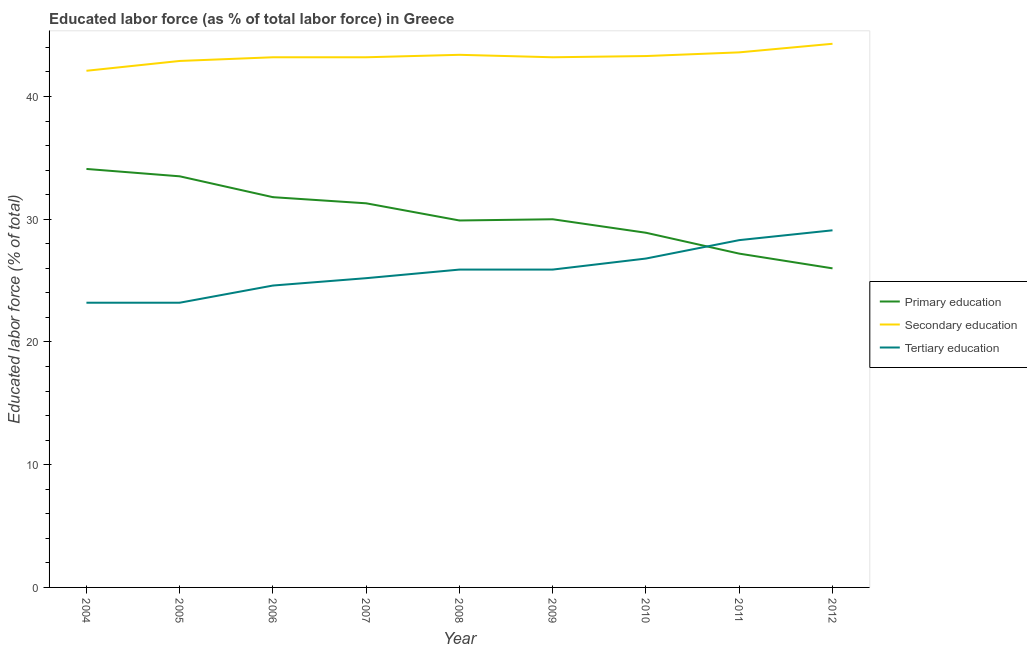How many different coloured lines are there?
Make the answer very short. 3. Does the line corresponding to percentage of labor force who received secondary education intersect with the line corresponding to percentage of labor force who received primary education?
Your answer should be very brief. No. What is the percentage of labor force who received tertiary education in 2011?
Offer a very short reply. 28.3. Across all years, what is the maximum percentage of labor force who received tertiary education?
Provide a short and direct response. 29.1. Across all years, what is the minimum percentage of labor force who received secondary education?
Give a very brief answer. 42.1. In which year was the percentage of labor force who received tertiary education maximum?
Your answer should be compact. 2012. What is the total percentage of labor force who received tertiary education in the graph?
Keep it short and to the point. 232.2. What is the difference between the percentage of labor force who received tertiary education in 2007 and that in 2011?
Give a very brief answer. -3.1. What is the difference between the percentage of labor force who received secondary education in 2007 and the percentage of labor force who received primary education in 2004?
Ensure brevity in your answer.  9.1. What is the average percentage of labor force who received primary education per year?
Offer a terse response. 30.3. In the year 2010, what is the difference between the percentage of labor force who received secondary education and percentage of labor force who received primary education?
Make the answer very short. 14.4. In how many years, is the percentage of labor force who received primary education greater than 6 %?
Your response must be concise. 9. What is the ratio of the percentage of labor force who received tertiary education in 2011 to that in 2012?
Keep it short and to the point. 0.97. Is the percentage of labor force who received secondary education in 2007 less than that in 2008?
Provide a short and direct response. Yes. What is the difference between the highest and the second highest percentage of labor force who received primary education?
Your answer should be compact. 0.6. What is the difference between the highest and the lowest percentage of labor force who received secondary education?
Offer a very short reply. 2.2. In how many years, is the percentage of labor force who received secondary education greater than the average percentage of labor force who received secondary education taken over all years?
Your response must be concise. 4. Is the percentage of labor force who received secondary education strictly less than the percentage of labor force who received primary education over the years?
Provide a succinct answer. No. Are the values on the major ticks of Y-axis written in scientific E-notation?
Your answer should be compact. No. Does the graph contain grids?
Give a very brief answer. No. Where does the legend appear in the graph?
Give a very brief answer. Center right. How many legend labels are there?
Your answer should be very brief. 3. What is the title of the graph?
Give a very brief answer. Educated labor force (as % of total labor force) in Greece. Does "Natural gas sources" appear as one of the legend labels in the graph?
Keep it short and to the point. No. What is the label or title of the X-axis?
Offer a terse response. Year. What is the label or title of the Y-axis?
Make the answer very short. Educated labor force (% of total). What is the Educated labor force (% of total) in Primary education in 2004?
Provide a succinct answer. 34.1. What is the Educated labor force (% of total) in Secondary education in 2004?
Provide a succinct answer. 42.1. What is the Educated labor force (% of total) in Tertiary education in 2004?
Provide a succinct answer. 23.2. What is the Educated labor force (% of total) of Primary education in 2005?
Your answer should be very brief. 33.5. What is the Educated labor force (% of total) in Secondary education in 2005?
Provide a short and direct response. 42.9. What is the Educated labor force (% of total) of Tertiary education in 2005?
Your response must be concise. 23.2. What is the Educated labor force (% of total) of Primary education in 2006?
Provide a succinct answer. 31.8. What is the Educated labor force (% of total) of Secondary education in 2006?
Offer a very short reply. 43.2. What is the Educated labor force (% of total) of Tertiary education in 2006?
Keep it short and to the point. 24.6. What is the Educated labor force (% of total) of Primary education in 2007?
Provide a short and direct response. 31.3. What is the Educated labor force (% of total) of Secondary education in 2007?
Provide a succinct answer. 43.2. What is the Educated labor force (% of total) in Tertiary education in 2007?
Provide a succinct answer. 25.2. What is the Educated labor force (% of total) in Primary education in 2008?
Ensure brevity in your answer.  29.9. What is the Educated labor force (% of total) of Secondary education in 2008?
Your answer should be compact. 43.4. What is the Educated labor force (% of total) of Tertiary education in 2008?
Keep it short and to the point. 25.9. What is the Educated labor force (% of total) of Secondary education in 2009?
Provide a short and direct response. 43.2. What is the Educated labor force (% of total) in Tertiary education in 2009?
Your answer should be very brief. 25.9. What is the Educated labor force (% of total) of Primary education in 2010?
Ensure brevity in your answer.  28.9. What is the Educated labor force (% of total) of Secondary education in 2010?
Your answer should be very brief. 43.3. What is the Educated labor force (% of total) in Tertiary education in 2010?
Your answer should be compact. 26.8. What is the Educated labor force (% of total) in Primary education in 2011?
Your answer should be very brief. 27.2. What is the Educated labor force (% of total) of Secondary education in 2011?
Provide a short and direct response. 43.6. What is the Educated labor force (% of total) in Tertiary education in 2011?
Offer a terse response. 28.3. What is the Educated labor force (% of total) in Primary education in 2012?
Ensure brevity in your answer.  26. What is the Educated labor force (% of total) in Secondary education in 2012?
Your answer should be compact. 44.3. What is the Educated labor force (% of total) of Tertiary education in 2012?
Provide a succinct answer. 29.1. Across all years, what is the maximum Educated labor force (% of total) in Primary education?
Offer a very short reply. 34.1. Across all years, what is the maximum Educated labor force (% of total) of Secondary education?
Make the answer very short. 44.3. Across all years, what is the maximum Educated labor force (% of total) in Tertiary education?
Your response must be concise. 29.1. Across all years, what is the minimum Educated labor force (% of total) in Secondary education?
Your answer should be compact. 42.1. Across all years, what is the minimum Educated labor force (% of total) in Tertiary education?
Offer a very short reply. 23.2. What is the total Educated labor force (% of total) in Primary education in the graph?
Your response must be concise. 272.7. What is the total Educated labor force (% of total) of Secondary education in the graph?
Ensure brevity in your answer.  389.2. What is the total Educated labor force (% of total) in Tertiary education in the graph?
Ensure brevity in your answer.  232.2. What is the difference between the Educated labor force (% of total) of Tertiary education in 2004 and that in 2005?
Your response must be concise. 0. What is the difference between the Educated labor force (% of total) of Primary education in 2004 and that in 2007?
Provide a short and direct response. 2.8. What is the difference between the Educated labor force (% of total) in Tertiary education in 2004 and that in 2007?
Offer a terse response. -2. What is the difference between the Educated labor force (% of total) of Primary education in 2004 and that in 2009?
Ensure brevity in your answer.  4.1. What is the difference between the Educated labor force (% of total) of Secondary education in 2004 and that in 2009?
Ensure brevity in your answer.  -1.1. What is the difference between the Educated labor force (% of total) of Tertiary education in 2004 and that in 2009?
Keep it short and to the point. -2.7. What is the difference between the Educated labor force (% of total) of Tertiary education in 2004 and that in 2010?
Keep it short and to the point. -3.6. What is the difference between the Educated labor force (% of total) in Primary education in 2004 and that in 2011?
Ensure brevity in your answer.  6.9. What is the difference between the Educated labor force (% of total) in Tertiary education in 2004 and that in 2011?
Offer a very short reply. -5.1. What is the difference between the Educated labor force (% of total) of Primary education in 2004 and that in 2012?
Offer a very short reply. 8.1. What is the difference between the Educated labor force (% of total) of Primary education in 2005 and that in 2006?
Give a very brief answer. 1.7. What is the difference between the Educated labor force (% of total) of Primary education in 2005 and that in 2007?
Keep it short and to the point. 2.2. What is the difference between the Educated labor force (% of total) in Tertiary education in 2005 and that in 2007?
Keep it short and to the point. -2. What is the difference between the Educated labor force (% of total) in Secondary education in 2005 and that in 2008?
Your response must be concise. -0.5. What is the difference between the Educated labor force (% of total) of Tertiary education in 2005 and that in 2008?
Make the answer very short. -2.7. What is the difference between the Educated labor force (% of total) of Secondary education in 2005 and that in 2011?
Offer a terse response. -0.7. What is the difference between the Educated labor force (% of total) of Tertiary education in 2005 and that in 2011?
Offer a very short reply. -5.1. What is the difference between the Educated labor force (% of total) of Primary education in 2005 and that in 2012?
Provide a succinct answer. 7.5. What is the difference between the Educated labor force (% of total) in Secondary education in 2005 and that in 2012?
Provide a short and direct response. -1.4. What is the difference between the Educated labor force (% of total) of Tertiary education in 2005 and that in 2012?
Ensure brevity in your answer.  -5.9. What is the difference between the Educated labor force (% of total) of Secondary education in 2006 and that in 2008?
Offer a very short reply. -0.2. What is the difference between the Educated labor force (% of total) of Tertiary education in 2006 and that in 2008?
Give a very brief answer. -1.3. What is the difference between the Educated labor force (% of total) in Primary education in 2006 and that in 2009?
Your response must be concise. 1.8. What is the difference between the Educated labor force (% of total) in Secondary education in 2006 and that in 2009?
Offer a very short reply. 0. What is the difference between the Educated labor force (% of total) in Tertiary education in 2006 and that in 2009?
Ensure brevity in your answer.  -1.3. What is the difference between the Educated labor force (% of total) of Primary education in 2006 and that in 2010?
Provide a succinct answer. 2.9. What is the difference between the Educated labor force (% of total) in Secondary education in 2006 and that in 2010?
Your answer should be very brief. -0.1. What is the difference between the Educated labor force (% of total) of Tertiary education in 2006 and that in 2010?
Keep it short and to the point. -2.2. What is the difference between the Educated labor force (% of total) of Secondary education in 2006 and that in 2011?
Ensure brevity in your answer.  -0.4. What is the difference between the Educated labor force (% of total) of Tertiary education in 2006 and that in 2011?
Provide a short and direct response. -3.7. What is the difference between the Educated labor force (% of total) in Primary education in 2006 and that in 2012?
Provide a succinct answer. 5.8. What is the difference between the Educated labor force (% of total) of Tertiary education in 2006 and that in 2012?
Provide a succinct answer. -4.5. What is the difference between the Educated labor force (% of total) of Tertiary education in 2007 and that in 2008?
Offer a terse response. -0.7. What is the difference between the Educated labor force (% of total) in Primary education in 2007 and that in 2009?
Keep it short and to the point. 1.3. What is the difference between the Educated labor force (% of total) of Tertiary education in 2007 and that in 2009?
Provide a short and direct response. -0.7. What is the difference between the Educated labor force (% of total) in Secondary education in 2007 and that in 2010?
Your answer should be very brief. -0.1. What is the difference between the Educated labor force (% of total) in Tertiary education in 2007 and that in 2010?
Ensure brevity in your answer.  -1.6. What is the difference between the Educated labor force (% of total) in Primary education in 2007 and that in 2011?
Keep it short and to the point. 4.1. What is the difference between the Educated labor force (% of total) of Secondary education in 2007 and that in 2011?
Keep it short and to the point. -0.4. What is the difference between the Educated labor force (% of total) of Tertiary education in 2007 and that in 2011?
Your answer should be very brief. -3.1. What is the difference between the Educated labor force (% of total) in Secondary education in 2007 and that in 2012?
Keep it short and to the point. -1.1. What is the difference between the Educated labor force (% of total) in Tertiary education in 2007 and that in 2012?
Make the answer very short. -3.9. What is the difference between the Educated labor force (% of total) of Primary education in 2008 and that in 2010?
Your response must be concise. 1. What is the difference between the Educated labor force (% of total) of Secondary education in 2008 and that in 2010?
Offer a very short reply. 0.1. What is the difference between the Educated labor force (% of total) in Tertiary education in 2008 and that in 2010?
Keep it short and to the point. -0.9. What is the difference between the Educated labor force (% of total) in Tertiary education in 2008 and that in 2011?
Your answer should be compact. -2.4. What is the difference between the Educated labor force (% of total) of Secondary education in 2008 and that in 2012?
Ensure brevity in your answer.  -0.9. What is the difference between the Educated labor force (% of total) in Primary education in 2009 and that in 2010?
Your answer should be very brief. 1.1. What is the difference between the Educated labor force (% of total) of Primary education in 2009 and that in 2011?
Provide a succinct answer. 2.8. What is the difference between the Educated labor force (% of total) in Secondary education in 2009 and that in 2011?
Offer a very short reply. -0.4. What is the difference between the Educated labor force (% of total) in Tertiary education in 2009 and that in 2011?
Your answer should be very brief. -2.4. What is the difference between the Educated labor force (% of total) of Secondary education in 2009 and that in 2012?
Provide a succinct answer. -1.1. What is the difference between the Educated labor force (% of total) in Secondary education in 2010 and that in 2011?
Keep it short and to the point. -0.3. What is the difference between the Educated labor force (% of total) in Tertiary education in 2010 and that in 2011?
Make the answer very short. -1.5. What is the difference between the Educated labor force (% of total) of Tertiary education in 2010 and that in 2012?
Make the answer very short. -2.3. What is the difference between the Educated labor force (% of total) of Primary education in 2011 and that in 2012?
Make the answer very short. 1.2. What is the difference between the Educated labor force (% of total) in Primary education in 2004 and the Educated labor force (% of total) in Secondary education in 2007?
Keep it short and to the point. -9.1. What is the difference between the Educated labor force (% of total) in Primary education in 2004 and the Educated labor force (% of total) in Tertiary education in 2007?
Ensure brevity in your answer.  8.9. What is the difference between the Educated labor force (% of total) in Primary education in 2004 and the Educated labor force (% of total) in Secondary education in 2008?
Offer a very short reply. -9.3. What is the difference between the Educated labor force (% of total) of Primary education in 2004 and the Educated labor force (% of total) of Tertiary education in 2008?
Give a very brief answer. 8.2. What is the difference between the Educated labor force (% of total) in Primary education in 2004 and the Educated labor force (% of total) in Secondary education in 2009?
Give a very brief answer. -9.1. What is the difference between the Educated labor force (% of total) of Primary education in 2004 and the Educated labor force (% of total) of Tertiary education in 2009?
Offer a very short reply. 8.2. What is the difference between the Educated labor force (% of total) of Primary education in 2004 and the Educated labor force (% of total) of Secondary education in 2010?
Make the answer very short. -9.2. What is the difference between the Educated labor force (% of total) of Secondary education in 2004 and the Educated labor force (% of total) of Tertiary education in 2010?
Keep it short and to the point. 15.3. What is the difference between the Educated labor force (% of total) of Primary education in 2004 and the Educated labor force (% of total) of Secondary education in 2011?
Your response must be concise. -9.5. What is the difference between the Educated labor force (% of total) in Primary education in 2004 and the Educated labor force (% of total) in Tertiary education in 2011?
Keep it short and to the point. 5.8. What is the difference between the Educated labor force (% of total) of Secondary education in 2004 and the Educated labor force (% of total) of Tertiary education in 2011?
Your answer should be compact. 13.8. What is the difference between the Educated labor force (% of total) of Primary education in 2004 and the Educated labor force (% of total) of Secondary education in 2012?
Your answer should be compact. -10.2. What is the difference between the Educated labor force (% of total) in Secondary education in 2005 and the Educated labor force (% of total) in Tertiary education in 2006?
Keep it short and to the point. 18.3. What is the difference between the Educated labor force (% of total) in Primary education in 2005 and the Educated labor force (% of total) in Secondary education in 2007?
Make the answer very short. -9.7. What is the difference between the Educated labor force (% of total) in Primary education in 2005 and the Educated labor force (% of total) in Secondary education in 2008?
Your response must be concise. -9.9. What is the difference between the Educated labor force (% of total) in Primary education in 2005 and the Educated labor force (% of total) in Tertiary education in 2008?
Make the answer very short. 7.6. What is the difference between the Educated labor force (% of total) of Primary education in 2005 and the Educated labor force (% of total) of Secondary education in 2009?
Offer a very short reply. -9.7. What is the difference between the Educated labor force (% of total) of Primary education in 2005 and the Educated labor force (% of total) of Tertiary education in 2009?
Provide a short and direct response. 7.6. What is the difference between the Educated labor force (% of total) in Secondary education in 2005 and the Educated labor force (% of total) in Tertiary education in 2009?
Give a very brief answer. 17. What is the difference between the Educated labor force (% of total) of Secondary education in 2005 and the Educated labor force (% of total) of Tertiary education in 2011?
Your answer should be very brief. 14.6. What is the difference between the Educated labor force (% of total) of Primary education in 2006 and the Educated labor force (% of total) of Secondary education in 2007?
Offer a very short reply. -11.4. What is the difference between the Educated labor force (% of total) in Secondary education in 2006 and the Educated labor force (% of total) in Tertiary education in 2007?
Your answer should be compact. 18. What is the difference between the Educated labor force (% of total) of Primary education in 2006 and the Educated labor force (% of total) of Secondary education in 2008?
Provide a succinct answer. -11.6. What is the difference between the Educated labor force (% of total) in Secondary education in 2006 and the Educated labor force (% of total) in Tertiary education in 2008?
Offer a very short reply. 17.3. What is the difference between the Educated labor force (% of total) in Primary education in 2006 and the Educated labor force (% of total) in Tertiary education in 2009?
Offer a very short reply. 5.9. What is the difference between the Educated labor force (% of total) of Primary education in 2006 and the Educated labor force (% of total) of Tertiary education in 2010?
Give a very brief answer. 5. What is the difference between the Educated labor force (% of total) of Secondary education in 2006 and the Educated labor force (% of total) of Tertiary education in 2010?
Your answer should be compact. 16.4. What is the difference between the Educated labor force (% of total) in Primary education in 2006 and the Educated labor force (% of total) in Secondary education in 2011?
Your answer should be very brief. -11.8. What is the difference between the Educated labor force (% of total) of Secondary education in 2006 and the Educated labor force (% of total) of Tertiary education in 2011?
Your answer should be compact. 14.9. What is the difference between the Educated labor force (% of total) of Primary education in 2006 and the Educated labor force (% of total) of Secondary education in 2012?
Your answer should be very brief. -12.5. What is the difference between the Educated labor force (% of total) of Secondary education in 2006 and the Educated labor force (% of total) of Tertiary education in 2012?
Offer a terse response. 14.1. What is the difference between the Educated labor force (% of total) of Primary education in 2007 and the Educated labor force (% of total) of Secondary education in 2008?
Your answer should be very brief. -12.1. What is the difference between the Educated labor force (% of total) in Primary education in 2007 and the Educated labor force (% of total) in Secondary education in 2009?
Provide a short and direct response. -11.9. What is the difference between the Educated labor force (% of total) in Secondary education in 2007 and the Educated labor force (% of total) in Tertiary education in 2009?
Offer a terse response. 17.3. What is the difference between the Educated labor force (% of total) in Primary education in 2007 and the Educated labor force (% of total) in Tertiary education in 2010?
Provide a short and direct response. 4.5. What is the difference between the Educated labor force (% of total) of Secondary education in 2007 and the Educated labor force (% of total) of Tertiary education in 2010?
Provide a succinct answer. 16.4. What is the difference between the Educated labor force (% of total) of Primary education in 2007 and the Educated labor force (% of total) of Secondary education in 2011?
Offer a very short reply. -12.3. What is the difference between the Educated labor force (% of total) in Secondary education in 2007 and the Educated labor force (% of total) in Tertiary education in 2011?
Offer a terse response. 14.9. What is the difference between the Educated labor force (% of total) of Primary education in 2007 and the Educated labor force (% of total) of Secondary education in 2012?
Offer a very short reply. -13. What is the difference between the Educated labor force (% of total) of Primary education in 2008 and the Educated labor force (% of total) of Secondary education in 2009?
Provide a short and direct response. -13.3. What is the difference between the Educated labor force (% of total) of Primary education in 2008 and the Educated labor force (% of total) of Tertiary education in 2009?
Offer a very short reply. 4. What is the difference between the Educated labor force (% of total) in Primary education in 2008 and the Educated labor force (% of total) in Secondary education in 2010?
Provide a succinct answer. -13.4. What is the difference between the Educated labor force (% of total) in Primary education in 2008 and the Educated labor force (% of total) in Tertiary education in 2010?
Provide a succinct answer. 3.1. What is the difference between the Educated labor force (% of total) in Primary education in 2008 and the Educated labor force (% of total) in Secondary education in 2011?
Give a very brief answer. -13.7. What is the difference between the Educated labor force (% of total) of Secondary education in 2008 and the Educated labor force (% of total) of Tertiary education in 2011?
Provide a succinct answer. 15.1. What is the difference between the Educated labor force (% of total) of Primary education in 2008 and the Educated labor force (% of total) of Secondary education in 2012?
Ensure brevity in your answer.  -14.4. What is the difference between the Educated labor force (% of total) in Primary education in 2009 and the Educated labor force (% of total) in Tertiary education in 2010?
Give a very brief answer. 3.2. What is the difference between the Educated labor force (% of total) of Primary education in 2009 and the Educated labor force (% of total) of Secondary education in 2011?
Provide a succinct answer. -13.6. What is the difference between the Educated labor force (% of total) in Primary education in 2009 and the Educated labor force (% of total) in Secondary education in 2012?
Your answer should be very brief. -14.3. What is the difference between the Educated labor force (% of total) of Primary education in 2009 and the Educated labor force (% of total) of Tertiary education in 2012?
Ensure brevity in your answer.  0.9. What is the difference between the Educated labor force (% of total) in Secondary education in 2009 and the Educated labor force (% of total) in Tertiary education in 2012?
Your response must be concise. 14.1. What is the difference between the Educated labor force (% of total) of Primary education in 2010 and the Educated labor force (% of total) of Secondary education in 2011?
Your answer should be compact. -14.7. What is the difference between the Educated labor force (% of total) in Primary education in 2010 and the Educated labor force (% of total) in Tertiary education in 2011?
Offer a terse response. 0.6. What is the difference between the Educated labor force (% of total) of Primary education in 2010 and the Educated labor force (% of total) of Secondary education in 2012?
Your answer should be very brief. -15.4. What is the difference between the Educated labor force (% of total) in Primary education in 2010 and the Educated labor force (% of total) in Tertiary education in 2012?
Give a very brief answer. -0.2. What is the difference between the Educated labor force (% of total) in Secondary education in 2010 and the Educated labor force (% of total) in Tertiary education in 2012?
Offer a terse response. 14.2. What is the difference between the Educated labor force (% of total) of Primary education in 2011 and the Educated labor force (% of total) of Secondary education in 2012?
Keep it short and to the point. -17.1. What is the average Educated labor force (% of total) in Primary education per year?
Keep it short and to the point. 30.3. What is the average Educated labor force (% of total) in Secondary education per year?
Your answer should be compact. 43.24. What is the average Educated labor force (% of total) of Tertiary education per year?
Provide a short and direct response. 25.8. In the year 2004, what is the difference between the Educated labor force (% of total) in Primary education and Educated labor force (% of total) in Secondary education?
Ensure brevity in your answer.  -8. In the year 2005, what is the difference between the Educated labor force (% of total) in Primary education and Educated labor force (% of total) in Secondary education?
Keep it short and to the point. -9.4. In the year 2006, what is the difference between the Educated labor force (% of total) in Primary education and Educated labor force (% of total) in Secondary education?
Provide a succinct answer. -11.4. In the year 2006, what is the difference between the Educated labor force (% of total) in Primary education and Educated labor force (% of total) in Tertiary education?
Offer a very short reply. 7.2. In the year 2007, what is the difference between the Educated labor force (% of total) of Primary education and Educated labor force (% of total) of Tertiary education?
Keep it short and to the point. 6.1. In the year 2008, what is the difference between the Educated labor force (% of total) in Primary education and Educated labor force (% of total) in Secondary education?
Ensure brevity in your answer.  -13.5. In the year 2009, what is the difference between the Educated labor force (% of total) in Secondary education and Educated labor force (% of total) in Tertiary education?
Your response must be concise. 17.3. In the year 2010, what is the difference between the Educated labor force (% of total) of Primary education and Educated labor force (% of total) of Secondary education?
Provide a short and direct response. -14.4. In the year 2010, what is the difference between the Educated labor force (% of total) of Secondary education and Educated labor force (% of total) of Tertiary education?
Your answer should be compact. 16.5. In the year 2011, what is the difference between the Educated labor force (% of total) in Primary education and Educated labor force (% of total) in Secondary education?
Your response must be concise. -16.4. In the year 2011, what is the difference between the Educated labor force (% of total) of Primary education and Educated labor force (% of total) of Tertiary education?
Keep it short and to the point. -1.1. In the year 2011, what is the difference between the Educated labor force (% of total) of Secondary education and Educated labor force (% of total) of Tertiary education?
Give a very brief answer. 15.3. In the year 2012, what is the difference between the Educated labor force (% of total) in Primary education and Educated labor force (% of total) in Secondary education?
Offer a terse response. -18.3. What is the ratio of the Educated labor force (% of total) in Primary education in 2004 to that in 2005?
Your answer should be compact. 1.02. What is the ratio of the Educated labor force (% of total) in Secondary education in 2004 to that in 2005?
Provide a succinct answer. 0.98. What is the ratio of the Educated labor force (% of total) in Primary education in 2004 to that in 2006?
Offer a very short reply. 1.07. What is the ratio of the Educated labor force (% of total) in Secondary education in 2004 to that in 2006?
Offer a very short reply. 0.97. What is the ratio of the Educated labor force (% of total) of Tertiary education in 2004 to that in 2006?
Your response must be concise. 0.94. What is the ratio of the Educated labor force (% of total) of Primary education in 2004 to that in 2007?
Provide a short and direct response. 1.09. What is the ratio of the Educated labor force (% of total) in Secondary education in 2004 to that in 2007?
Your answer should be compact. 0.97. What is the ratio of the Educated labor force (% of total) of Tertiary education in 2004 to that in 2007?
Keep it short and to the point. 0.92. What is the ratio of the Educated labor force (% of total) in Primary education in 2004 to that in 2008?
Your answer should be very brief. 1.14. What is the ratio of the Educated labor force (% of total) in Secondary education in 2004 to that in 2008?
Offer a very short reply. 0.97. What is the ratio of the Educated labor force (% of total) in Tertiary education in 2004 to that in 2008?
Your answer should be very brief. 0.9. What is the ratio of the Educated labor force (% of total) of Primary education in 2004 to that in 2009?
Offer a very short reply. 1.14. What is the ratio of the Educated labor force (% of total) of Secondary education in 2004 to that in 2009?
Your response must be concise. 0.97. What is the ratio of the Educated labor force (% of total) of Tertiary education in 2004 to that in 2009?
Offer a very short reply. 0.9. What is the ratio of the Educated labor force (% of total) of Primary education in 2004 to that in 2010?
Offer a very short reply. 1.18. What is the ratio of the Educated labor force (% of total) in Secondary education in 2004 to that in 2010?
Ensure brevity in your answer.  0.97. What is the ratio of the Educated labor force (% of total) of Tertiary education in 2004 to that in 2010?
Offer a very short reply. 0.87. What is the ratio of the Educated labor force (% of total) of Primary education in 2004 to that in 2011?
Make the answer very short. 1.25. What is the ratio of the Educated labor force (% of total) in Secondary education in 2004 to that in 2011?
Your response must be concise. 0.97. What is the ratio of the Educated labor force (% of total) in Tertiary education in 2004 to that in 2011?
Your answer should be compact. 0.82. What is the ratio of the Educated labor force (% of total) of Primary education in 2004 to that in 2012?
Keep it short and to the point. 1.31. What is the ratio of the Educated labor force (% of total) in Secondary education in 2004 to that in 2012?
Give a very brief answer. 0.95. What is the ratio of the Educated labor force (% of total) of Tertiary education in 2004 to that in 2012?
Offer a very short reply. 0.8. What is the ratio of the Educated labor force (% of total) of Primary education in 2005 to that in 2006?
Keep it short and to the point. 1.05. What is the ratio of the Educated labor force (% of total) of Secondary education in 2005 to that in 2006?
Provide a short and direct response. 0.99. What is the ratio of the Educated labor force (% of total) in Tertiary education in 2005 to that in 2006?
Make the answer very short. 0.94. What is the ratio of the Educated labor force (% of total) of Primary education in 2005 to that in 2007?
Your answer should be very brief. 1.07. What is the ratio of the Educated labor force (% of total) in Secondary education in 2005 to that in 2007?
Ensure brevity in your answer.  0.99. What is the ratio of the Educated labor force (% of total) of Tertiary education in 2005 to that in 2007?
Ensure brevity in your answer.  0.92. What is the ratio of the Educated labor force (% of total) in Primary education in 2005 to that in 2008?
Offer a very short reply. 1.12. What is the ratio of the Educated labor force (% of total) of Tertiary education in 2005 to that in 2008?
Give a very brief answer. 0.9. What is the ratio of the Educated labor force (% of total) of Primary education in 2005 to that in 2009?
Offer a terse response. 1.12. What is the ratio of the Educated labor force (% of total) of Secondary education in 2005 to that in 2009?
Give a very brief answer. 0.99. What is the ratio of the Educated labor force (% of total) in Tertiary education in 2005 to that in 2009?
Your answer should be compact. 0.9. What is the ratio of the Educated labor force (% of total) of Primary education in 2005 to that in 2010?
Keep it short and to the point. 1.16. What is the ratio of the Educated labor force (% of total) in Tertiary education in 2005 to that in 2010?
Offer a very short reply. 0.87. What is the ratio of the Educated labor force (% of total) of Primary education in 2005 to that in 2011?
Your answer should be compact. 1.23. What is the ratio of the Educated labor force (% of total) in Secondary education in 2005 to that in 2011?
Offer a terse response. 0.98. What is the ratio of the Educated labor force (% of total) of Tertiary education in 2005 to that in 2011?
Make the answer very short. 0.82. What is the ratio of the Educated labor force (% of total) in Primary education in 2005 to that in 2012?
Ensure brevity in your answer.  1.29. What is the ratio of the Educated labor force (% of total) in Secondary education in 2005 to that in 2012?
Keep it short and to the point. 0.97. What is the ratio of the Educated labor force (% of total) of Tertiary education in 2005 to that in 2012?
Give a very brief answer. 0.8. What is the ratio of the Educated labor force (% of total) in Secondary education in 2006 to that in 2007?
Provide a succinct answer. 1. What is the ratio of the Educated labor force (% of total) in Tertiary education in 2006 to that in 2007?
Your answer should be very brief. 0.98. What is the ratio of the Educated labor force (% of total) in Primary education in 2006 to that in 2008?
Offer a terse response. 1.06. What is the ratio of the Educated labor force (% of total) of Secondary education in 2006 to that in 2008?
Give a very brief answer. 1. What is the ratio of the Educated labor force (% of total) in Tertiary education in 2006 to that in 2008?
Provide a short and direct response. 0.95. What is the ratio of the Educated labor force (% of total) in Primary education in 2006 to that in 2009?
Offer a terse response. 1.06. What is the ratio of the Educated labor force (% of total) in Secondary education in 2006 to that in 2009?
Your answer should be compact. 1. What is the ratio of the Educated labor force (% of total) in Tertiary education in 2006 to that in 2009?
Your response must be concise. 0.95. What is the ratio of the Educated labor force (% of total) in Primary education in 2006 to that in 2010?
Your answer should be compact. 1.1. What is the ratio of the Educated labor force (% of total) in Tertiary education in 2006 to that in 2010?
Make the answer very short. 0.92. What is the ratio of the Educated labor force (% of total) in Primary education in 2006 to that in 2011?
Keep it short and to the point. 1.17. What is the ratio of the Educated labor force (% of total) of Tertiary education in 2006 to that in 2011?
Keep it short and to the point. 0.87. What is the ratio of the Educated labor force (% of total) of Primary education in 2006 to that in 2012?
Give a very brief answer. 1.22. What is the ratio of the Educated labor force (% of total) in Secondary education in 2006 to that in 2012?
Provide a short and direct response. 0.98. What is the ratio of the Educated labor force (% of total) in Tertiary education in 2006 to that in 2012?
Make the answer very short. 0.85. What is the ratio of the Educated labor force (% of total) in Primary education in 2007 to that in 2008?
Offer a very short reply. 1.05. What is the ratio of the Educated labor force (% of total) in Secondary education in 2007 to that in 2008?
Ensure brevity in your answer.  1. What is the ratio of the Educated labor force (% of total) in Primary education in 2007 to that in 2009?
Offer a very short reply. 1.04. What is the ratio of the Educated labor force (% of total) in Secondary education in 2007 to that in 2009?
Your answer should be very brief. 1. What is the ratio of the Educated labor force (% of total) of Primary education in 2007 to that in 2010?
Offer a very short reply. 1.08. What is the ratio of the Educated labor force (% of total) of Secondary education in 2007 to that in 2010?
Provide a succinct answer. 1. What is the ratio of the Educated labor force (% of total) in Tertiary education in 2007 to that in 2010?
Your response must be concise. 0.94. What is the ratio of the Educated labor force (% of total) in Primary education in 2007 to that in 2011?
Provide a succinct answer. 1.15. What is the ratio of the Educated labor force (% of total) in Secondary education in 2007 to that in 2011?
Offer a terse response. 0.99. What is the ratio of the Educated labor force (% of total) in Tertiary education in 2007 to that in 2011?
Your answer should be compact. 0.89. What is the ratio of the Educated labor force (% of total) of Primary education in 2007 to that in 2012?
Your answer should be very brief. 1.2. What is the ratio of the Educated labor force (% of total) of Secondary education in 2007 to that in 2012?
Your response must be concise. 0.98. What is the ratio of the Educated labor force (% of total) in Tertiary education in 2007 to that in 2012?
Offer a very short reply. 0.87. What is the ratio of the Educated labor force (% of total) in Secondary education in 2008 to that in 2009?
Make the answer very short. 1. What is the ratio of the Educated labor force (% of total) of Tertiary education in 2008 to that in 2009?
Offer a terse response. 1. What is the ratio of the Educated labor force (% of total) of Primary education in 2008 to that in 2010?
Your answer should be compact. 1.03. What is the ratio of the Educated labor force (% of total) in Secondary education in 2008 to that in 2010?
Provide a succinct answer. 1. What is the ratio of the Educated labor force (% of total) in Tertiary education in 2008 to that in 2010?
Keep it short and to the point. 0.97. What is the ratio of the Educated labor force (% of total) in Primary education in 2008 to that in 2011?
Keep it short and to the point. 1.1. What is the ratio of the Educated labor force (% of total) in Secondary education in 2008 to that in 2011?
Ensure brevity in your answer.  1. What is the ratio of the Educated labor force (% of total) in Tertiary education in 2008 to that in 2011?
Make the answer very short. 0.92. What is the ratio of the Educated labor force (% of total) of Primary education in 2008 to that in 2012?
Ensure brevity in your answer.  1.15. What is the ratio of the Educated labor force (% of total) in Secondary education in 2008 to that in 2012?
Your response must be concise. 0.98. What is the ratio of the Educated labor force (% of total) in Tertiary education in 2008 to that in 2012?
Your response must be concise. 0.89. What is the ratio of the Educated labor force (% of total) in Primary education in 2009 to that in 2010?
Your answer should be very brief. 1.04. What is the ratio of the Educated labor force (% of total) in Tertiary education in 2009 to that in 2010?
Offer a terse response. 0.97. What is the ratio of the Educated labor force (% of total) in Primary education in 2009 to that in 2011?
Your answer should be compact. 1.1. What is the ratio of the Educated labor force (% of total) in Secondary education in 2009 to that in 2011?
Keep it short and to the point. 0.99. What is the ratio of the Educated labor force (% of total) in Tertiary education in 2009 to that in 2011?
Your answer should be very brief. 0.92. What is the ratio of the Educated labor force (% of total) of Primary education in 2009 to that in 2012?
Offer a very short reply. 1.15. What is the ratio of the Educated labor force (% of total) of Secondary education in 2009 to that in 2012?
Your answer should be very brief. 0.98. What is the ratio of the Educated labor force (% of total) in Tertiary education in 2009 to that in 2012?
Provide a short and direct response. 0.89. What is the ratio of the Educated labor force (% of total) in Secondary education in 2010 to that in 2011?
Offer a very short reply. 0.99. What is the ratio of the Educated labor force (% of total) in Tertiary education in 2010 to that in 2011?
Make the answer very short. 0.95. What is the ratio of the Educated labor force (% of total) in Primary education in 2010 to that in 2012?
Make the answer very short. 1.11. What is the ratio of the Educated labor force (% of total) in Secondary education in 2010 to that in 2012?
Your answer should be compact. 0.98. What is the ratio of the Educated labor force (% of total) in Tertiary education in 2010 to that in 2012?
Give a very brief answer. 0.92. What is the ratio of the Educated labor force (% of total) in Primary education in 2011 to that in 2012?
Make the answer very short. 1.05. What is the ratio of the Educated labor force (% of total) in Secondary education in 2011 to that in 2012?
Make the answer very short. 0.98. What is the ratio of the Educated labor force (% of total) of Tertiary education in 2011 to that in 2012?
Offer a terse response. 0.97. What is the difference between the highest and the second highest Educated labor force (% of total) of Primary education?
Offer a very short reply. 0.6. What is the difference between the highest and the lowest Educated labor force (% of total) of Primary education?
Offer a very short reply. 8.1. What is the difference between the highest and the lowest Educated labor force (% of total) of Tertiary education?
Keep it short and to the point. 5.9. 